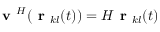<formula> <loc_0><loc_0><loc_500><loc_500>v ^ { H } ( r _ { k l } ( t ) ) = H r _ { k l } ( t )</formula> 